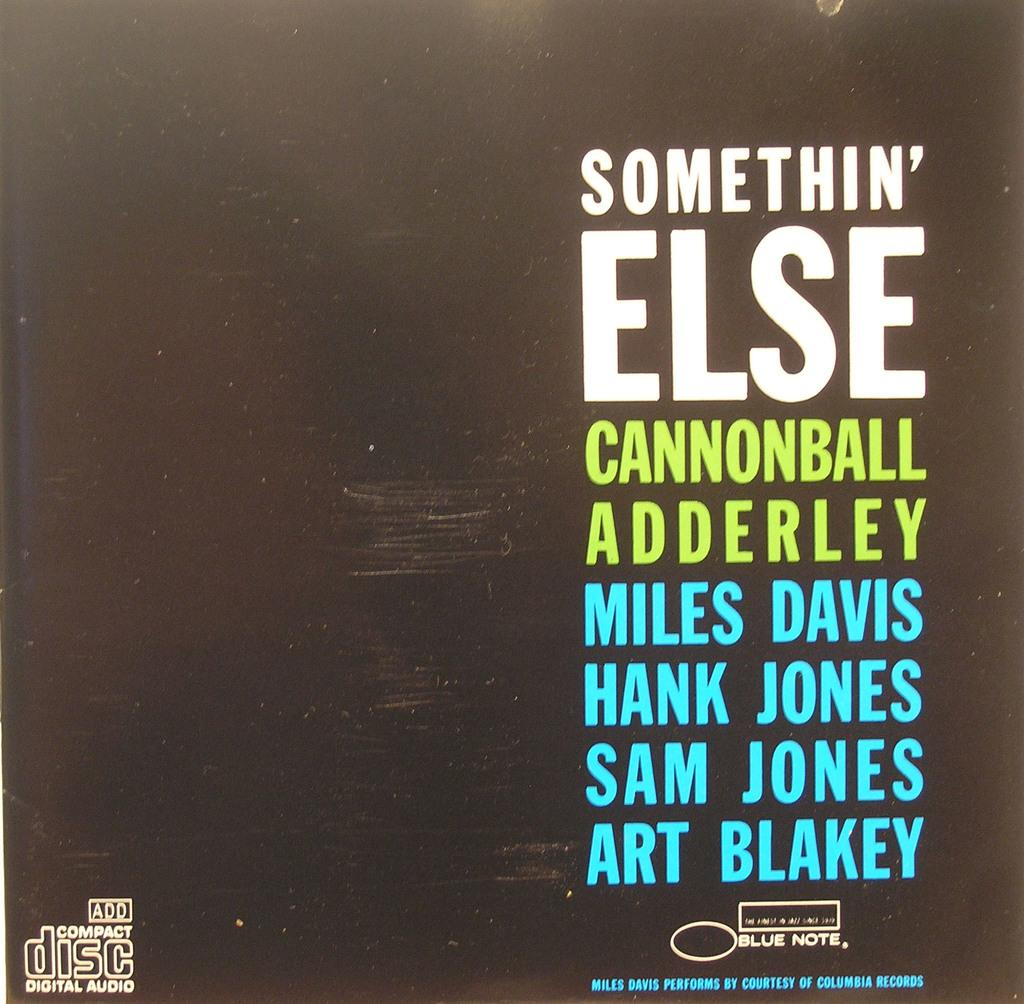<image>
Summarize the visual content of the image. A record called "Somethin' Else" produced by Columbia Records. 